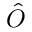Convert formula to latex. <formula><loc_0><loc_0><loc_500><loc_500>\hat { O }</formula> 